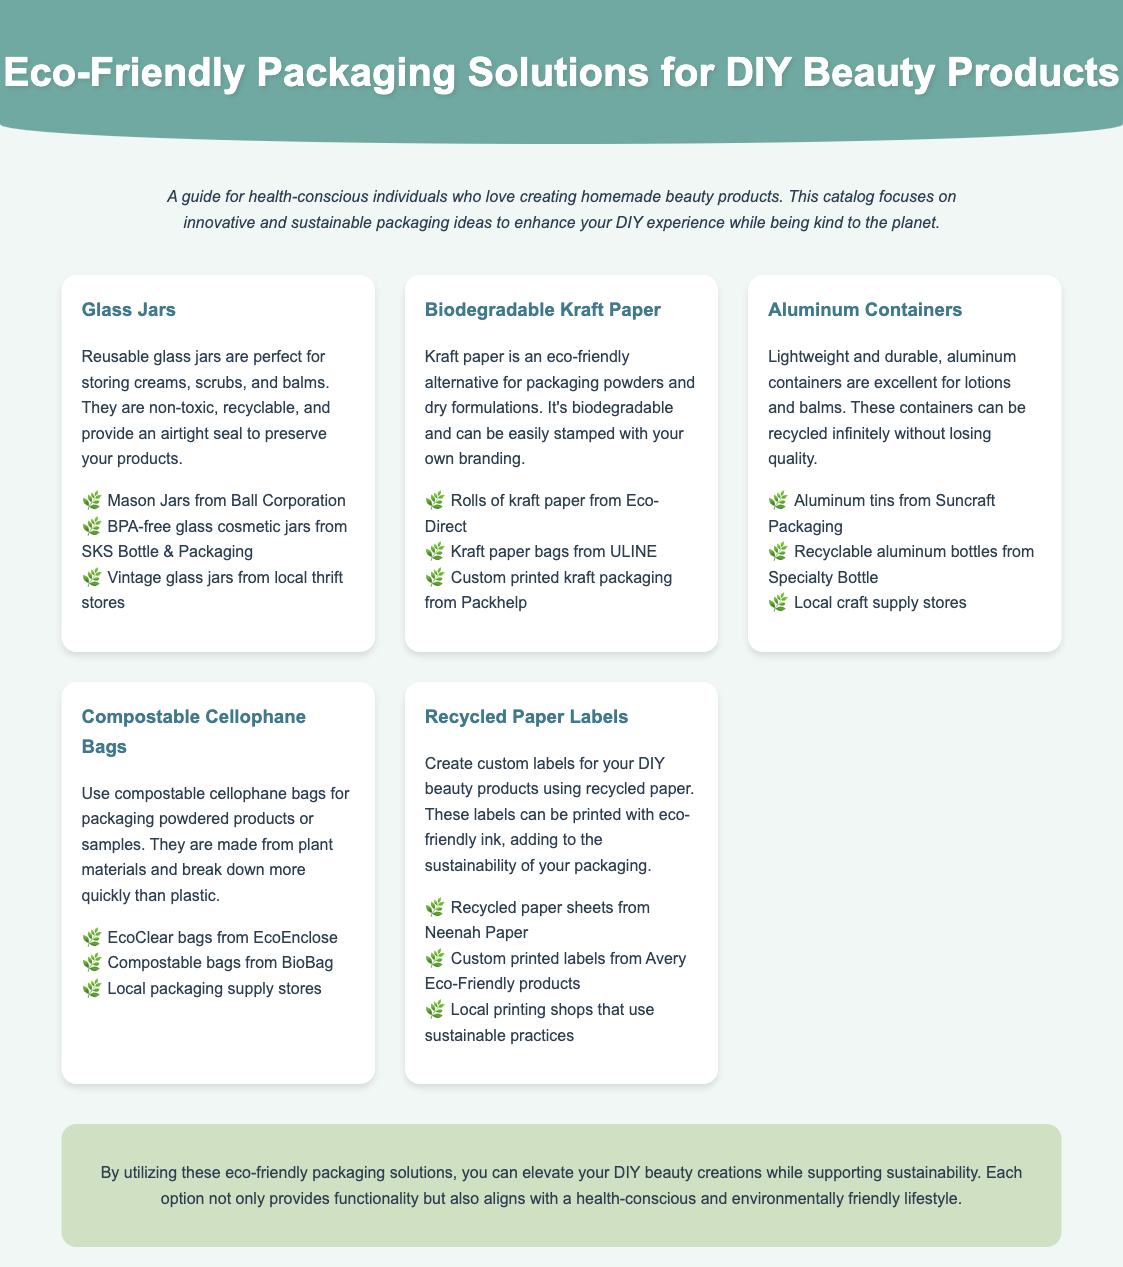What are the benefits of using glass jars? The document states that glass jars are non-toxic, recyclable, and provide an airtight seal to preserve products.
Answer: Non-toxic, recyclable, airtight seal Where can I source biodegradable kraft paper? The document lists sourcing options, including Eco-Direct, ULINE, and Packhelp.
Answer: Eco-Direct What type of containers are recycled infinitely without losing quality? The document mentions that aluminum containers can be recycled infinitely without losing quality.
Answer: Aluminum containers What material are compostable cellophane bags made from? The document indicates that compostable cellophane bags are made from plant materials.
Answer: Plant materials What type of ink can be used with recycled paper labels? The document suggests using eco-friendly ink for printing on recycled paper labels.
Answer: Eco-friendly ink Why should I consider using compostable cellophane bags? Compostable cellophane bags break down more quickly than plastic and are made from plant materials.
Answer: Break down quickly, made from plant materials How many packaging options are listed in the catalog? The document presents a total of five different packaging options for DIY beauty products.
Answer: Five What does the conclusion emphasize about the packaging solutions? The conclusion stresses that the packaging solutions support sustainability while enhancing DIY beauty creations.
Answer: Support sustainability Which specific stores are recommended for sourcing aluminum tins? The document recommends sourcing aluminum tins from Suncraft Packaging.
Answer: Suncraft Packaging 